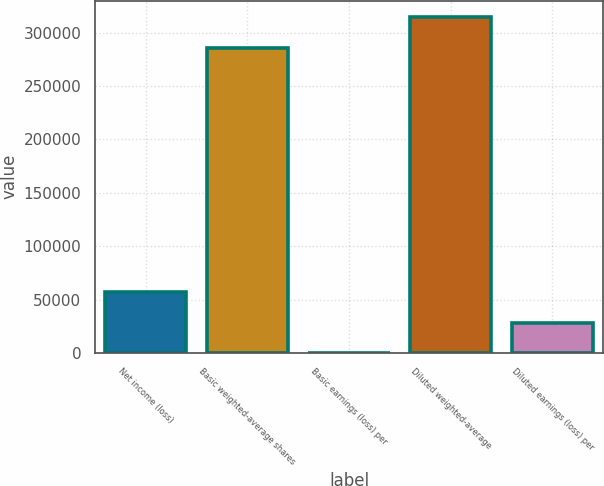Convert chart to OTSL. <chart><loc_0><loc_0><loc_500><loc_500><bar_chart><fcel>Net income (loss)<fcel>Basic weighted-average shares<fcel>Basic earnings (loss) per<fcel>Diluted weighted-average<fcel>Diluted earnings (loss) per<nl><fcel>57149.9<fcel>285748<fcel>0.39<fcel>314323<fcel>28575.2<nl></chart> 